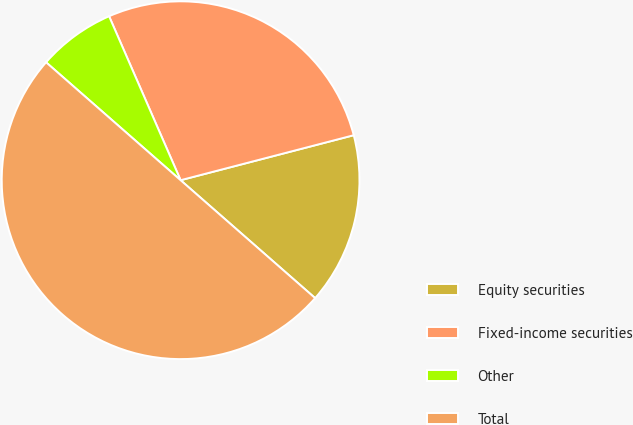<chart> <loc_0><loc_0><loc_500><loc_500><pie_chart><fcel>Equity securities<fcel>Fixed-income securities<fcel>Other<fcel>Total<nl><fcel>15.5%<fcel>27.5%<fcel>7.0%<fcel>50.0%<nl></chart> 